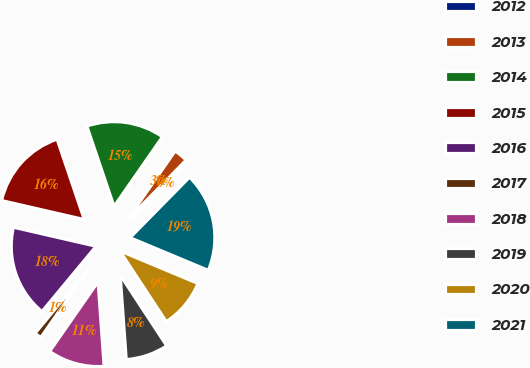Convert chart. <chart><loc_0><loc_0><loc_500><loc_500><pie_chart><fcel>2012<fcel>2013<fcel>2014<fcel>2015<fcel>2016<fcel>2017<fcel>2018<fcel>2019<fcel>2020<fcel>2021<nl><fcel>0.0%<fcel>2.7%<fcel>14.86%<fcel>16.21%<fcel>17.57%<fcel>1.35%<fcel>10.81%<fcel>8.11%<fcel>9.46%<fcel>18.92%<nl></chart> 